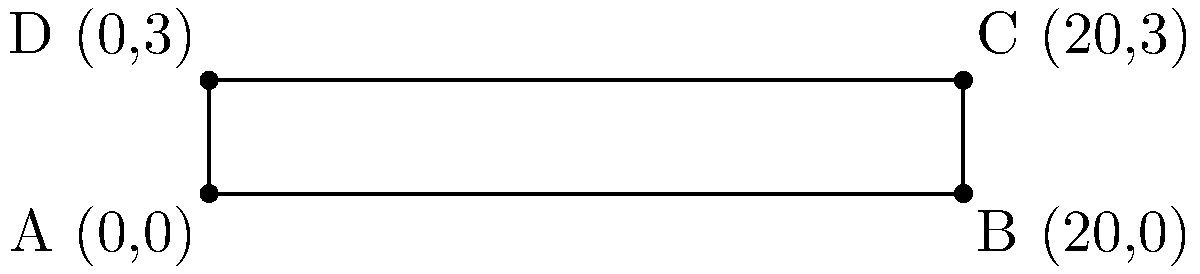On a coordinate system, a cricket pitch is represented as a rectangle with vertices A(0,0), B(20,0), C(20,3), and D(0,3). Calculate the area of the cricket pitch in square units. To find the area of the rectangular cricket pitch, we need to follow these steps:

1. Identify the length and width of the rectangle:
   - Length: The distance between points A and B (or D and C) along the x-axis
   - Width: The distance between points A and D (or B and C) along the y-axis

2. Calculate the length:
   Length = x-coordinate of B - x-coordinate of A
   $$ \text{Length} = 20 - 0 = 20 \text{ units} $$

3. Calculate the width:
   Width = y-coordinate of D - y-coordinate of A
   $$ \text{Width} = 3 - 0 = 3 \text{ units} $$

4. Apply the formula for the area of a rectangle:
   $$ \text{Area} = \text{Length} \times \text{Width} $$

5. Substitute the values and calculate:
   $$ \text{Area} = 20 \times 3 = 60 \text{ square units} $$

Therefore, the area of the cricket pitch represented on the coordinate system is 60 square units.
Answer: 60 square units 